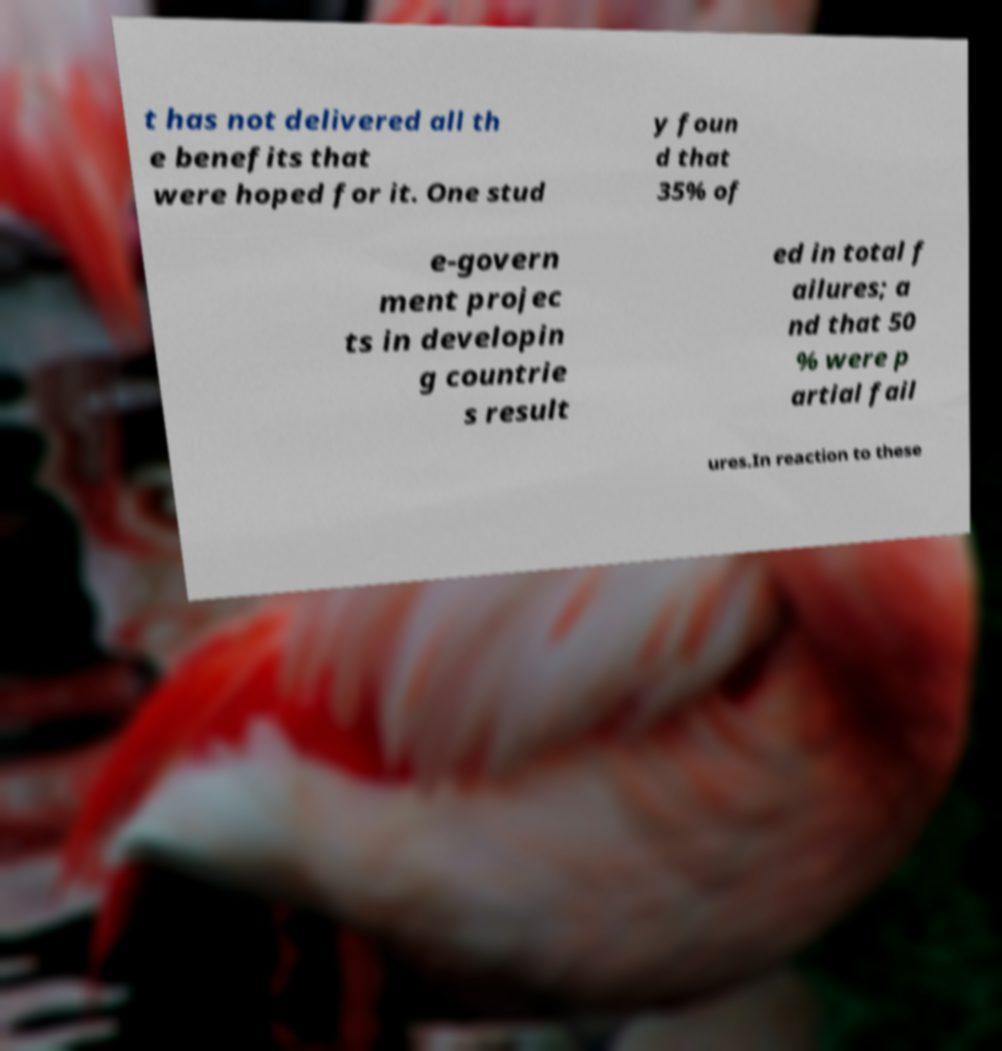Could you assist in decoding the text presented in this image and type it out clearly? t has not delivered all th e benefits that were hoped for it. One stud y foun d that 35% of e-govern ment projec ts in developin g countrie s result ed in total f ailures; a nd that 50 % were p artial fail ures.In reaction to these 